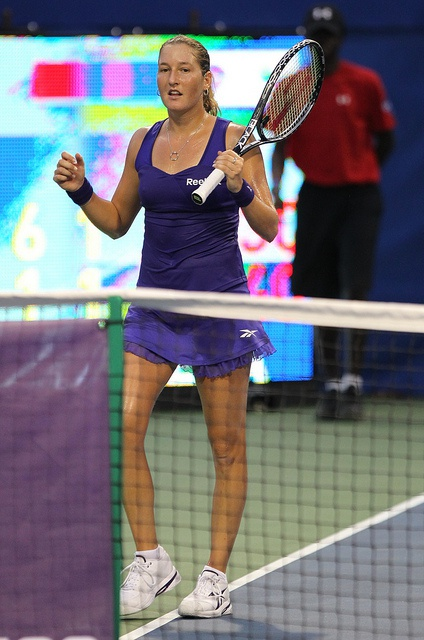Describe the objects in this image and their specific colors. I can see people in navy, brown, gray, and black tones, people in navy, black, and maroon tones, and tennis racket in navy, black, lightgray, maroon, and gray tones in this image. 